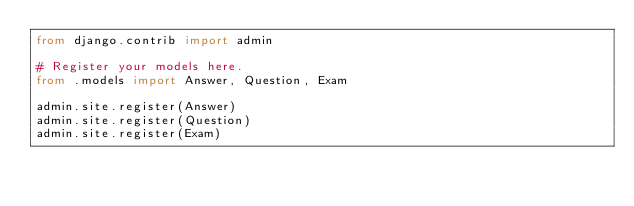Convert code to text. <code><loc_0><loc_0><loc_500><loc_500><_Python_>from django.contrib import admin

# Register your models here.
from .models import Answer, Question, Exam

admin.site.register(Answer)
admin.site.register(Question)
admin.site.register(Exam)</code> 